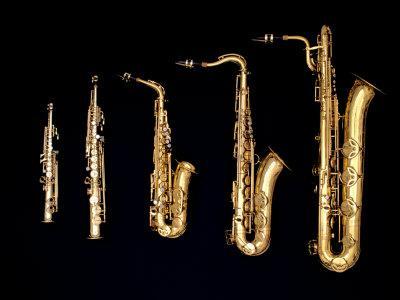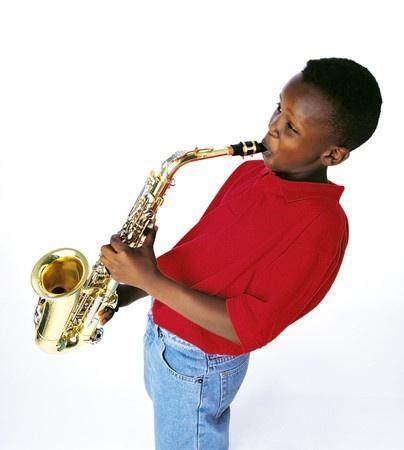The first image is the image on the left, the second image is the image on the right. Considering the images on both sides, is "In one image, a child wearing jeans is leaning back as he or she plays a saxophone." valid? Answer yes or no. Yes. The first image is the image on the left, the second image is the image on the right. Examine the images to the left and right. Is the description "The right image contains a human child playing a saxophone." accurate? Answer yes or no. Yes. The first image is the image on the left, the second image is the image on the right. Examine the images to the left and right. Is the description "In one of the images there is a child playing a saxophone." accurate? Answer yes or no. Yes. The first image is the image on the left, the second image is the image on the right. For the images displayed, is the sentence "In one image, a child wearing jeans is leaning back as he or she plays a saxophone." factually correct? Answer yes or no. Yes. 